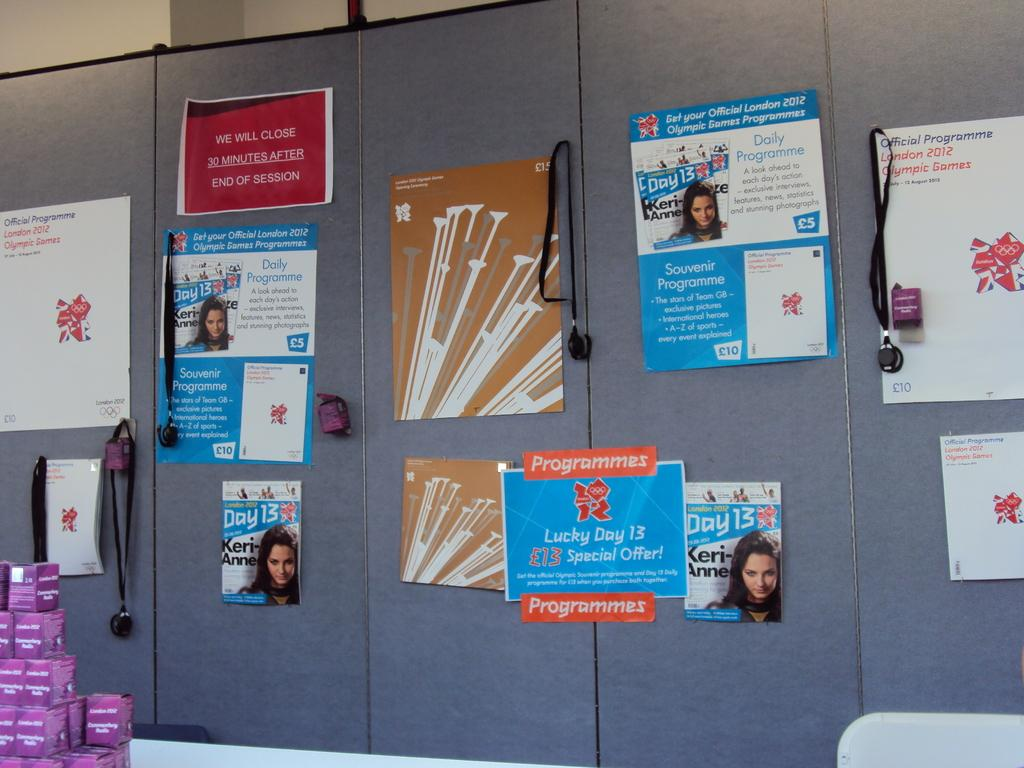What is on the board that is visible in the image? There is a board with posters in the image. What can be seen near the wall in the image? There are objects near the wall in the image. What type of furniture is in the image? There is a chair in the image. What is on the table in the image? There are objects on a table in the image. What type of oven is visible in the image? There is no oven present in the image. What type of agreement is being made in the image? There is no agreement being made in the image; it only shows a board with posters, objects near the wall, a chair, and objects on a table. 